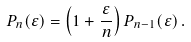Convert formula to latex. <formula><loc_0><loc_0><loc_500><loc_500>P _ { n } ( \varepsilon ) = \left ( 1 + \frac { \varepsilon } { n } \right ) P _ { n - 1 } ( \varepsilon ) \, .</formula> 